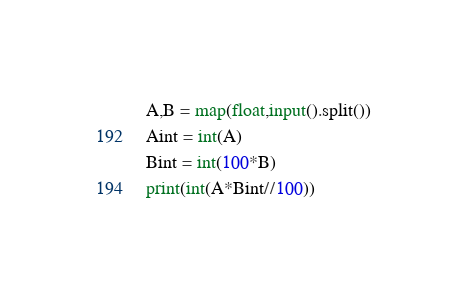Convert code to text. <code><loc_0><loc_0><loc_500><loc_500><_Python_>A,B = map(float,input().split())
Aint = int(A)
Bint = int(100*B)
print(int(A*Bint//100))</code> 